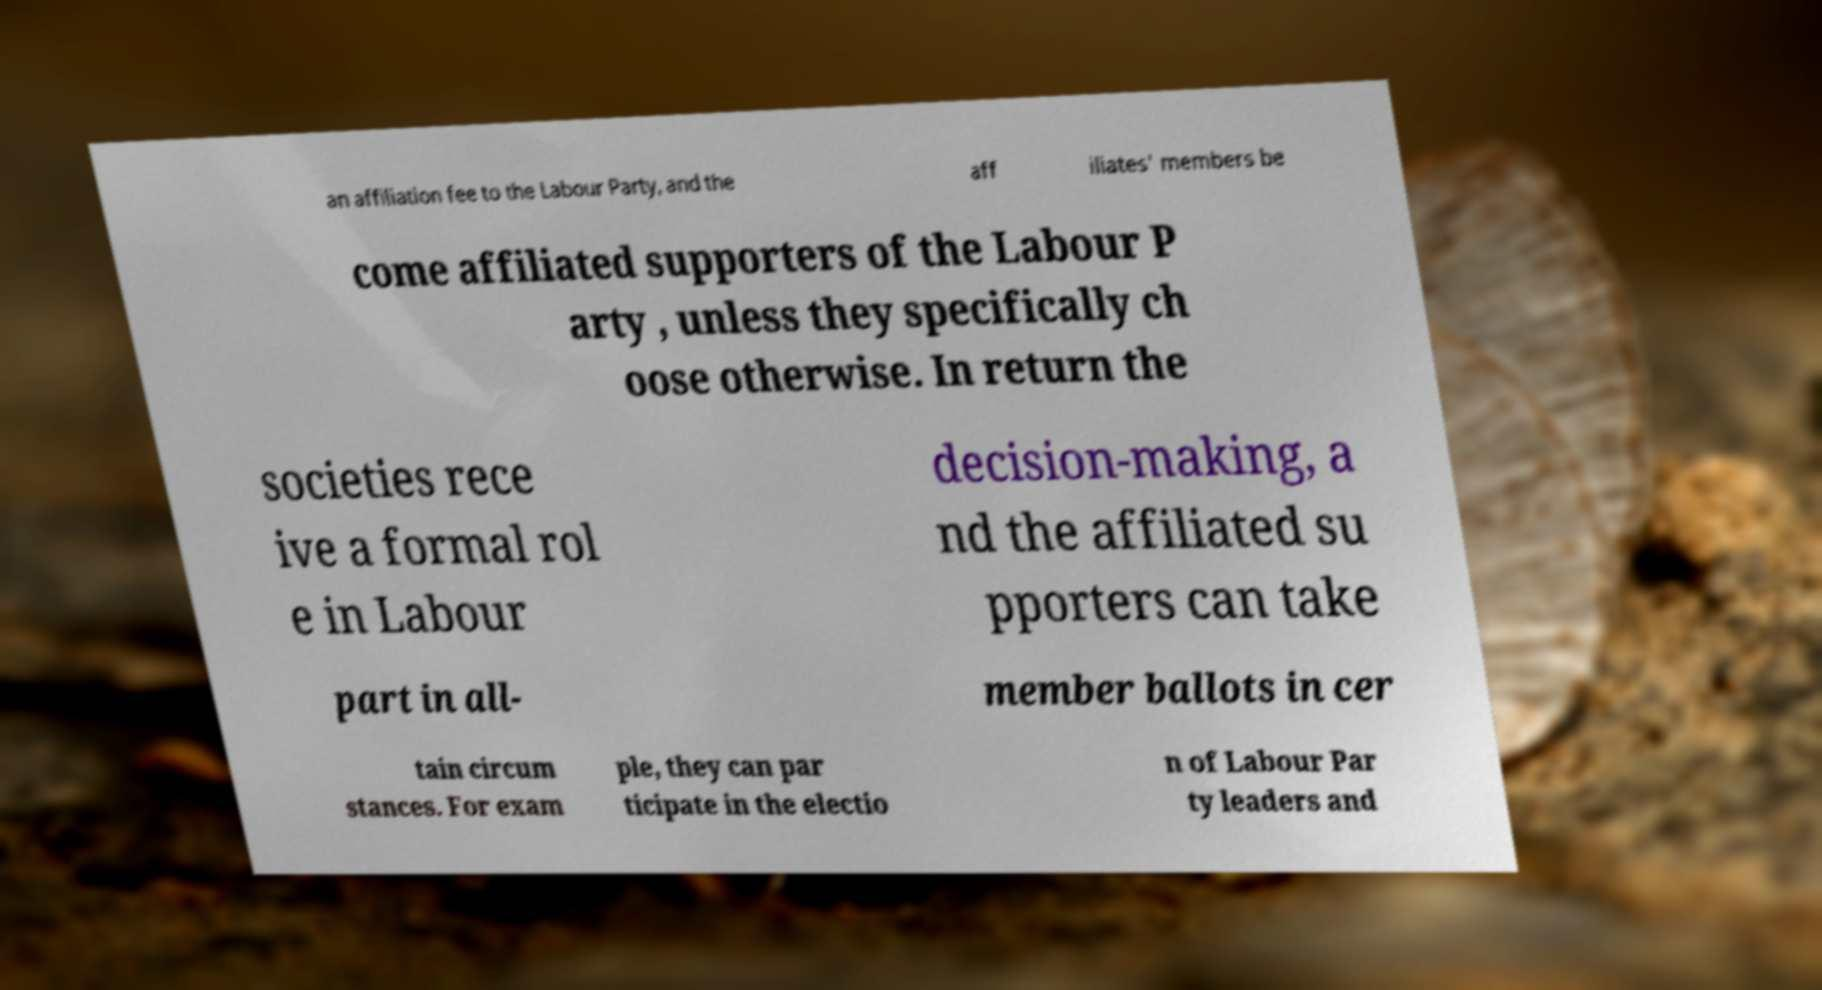Could you assist in decoding the text presented in this image and type it out clearly? an affiliation fee to the Labour Party, and the aff iliates' members be come affiliated supporters of the Labour P arty , unless they specifically ch oose otherwise. In return the societies rece ive a formal rol e in Labour decision-making, a nd the affiliated su pporters can take part in all- member ballots in cer tain circum stances. For exam ple, they can par ticipate in the electio n of Labour Par ty leaders and 